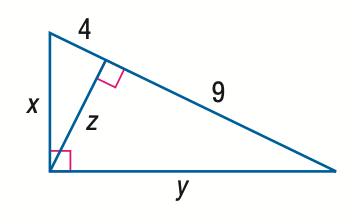Answer the mathemtical geometry problem and directly provide the correct option letter.
Question: Find x.
Choices: A: 4 B: 2 \sqrt { 5 } C: 6 D: 2 \sqrt { 13 } D 